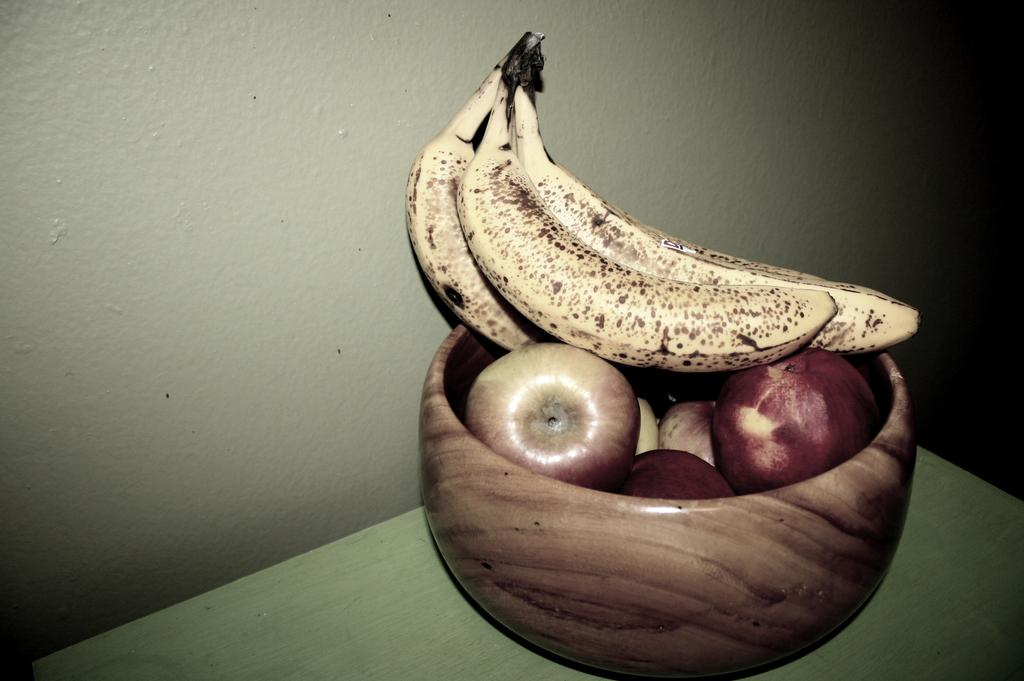What is in the bowl that is visible in the image? The bowl contains apples and bananas. Where is the bowl located in the image? The bowl is placed on a table. What can be seen in the background of the image? There is a wall in the background of the image. What type of doll is sitting on the table next to the bowl? There is no doll present in the image; the image only features a bowl with apples and bananas on a table. 